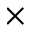Convert formula to latex. <formula><loc_0><loc_0><loc_500><loc_500>\times</formula> 